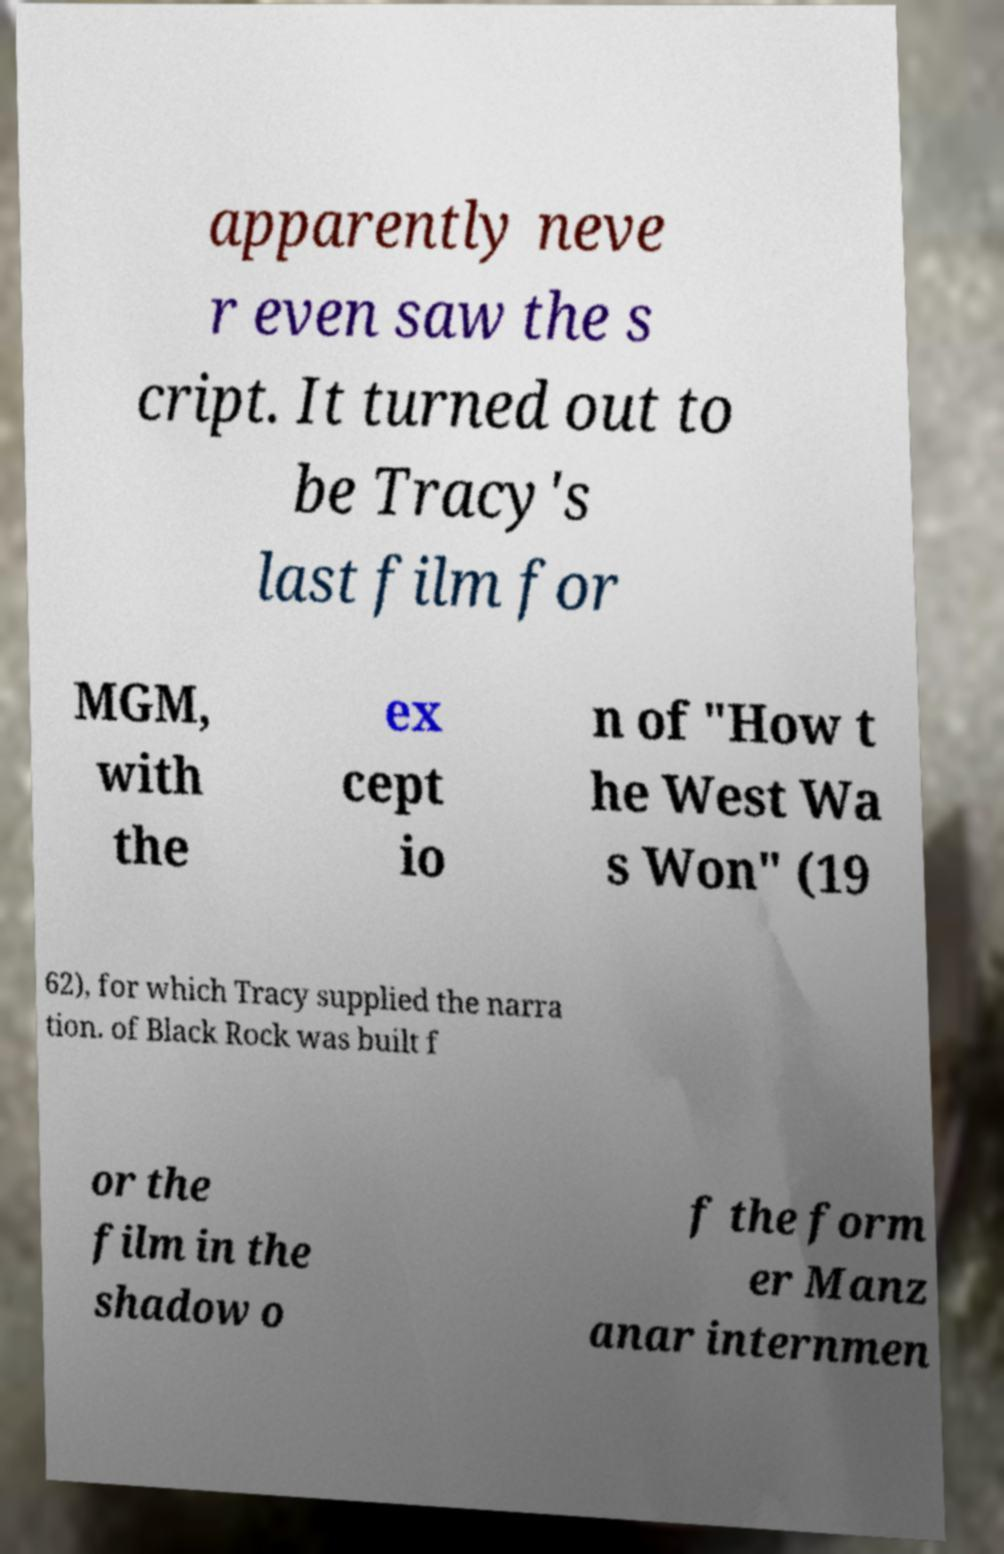For documentation purposes, I need the text within this image transcribed. Could you provide that? apparently neve r even saw the s cript. It turned out to be Tracy's last film for MGM, with the ex cept io n of "How t he West Wa s Won" (19 62), for which Tracy supplied the narra tion. of Black Rock was built f or the film in the shadow o f the form er Manz anar internmen 